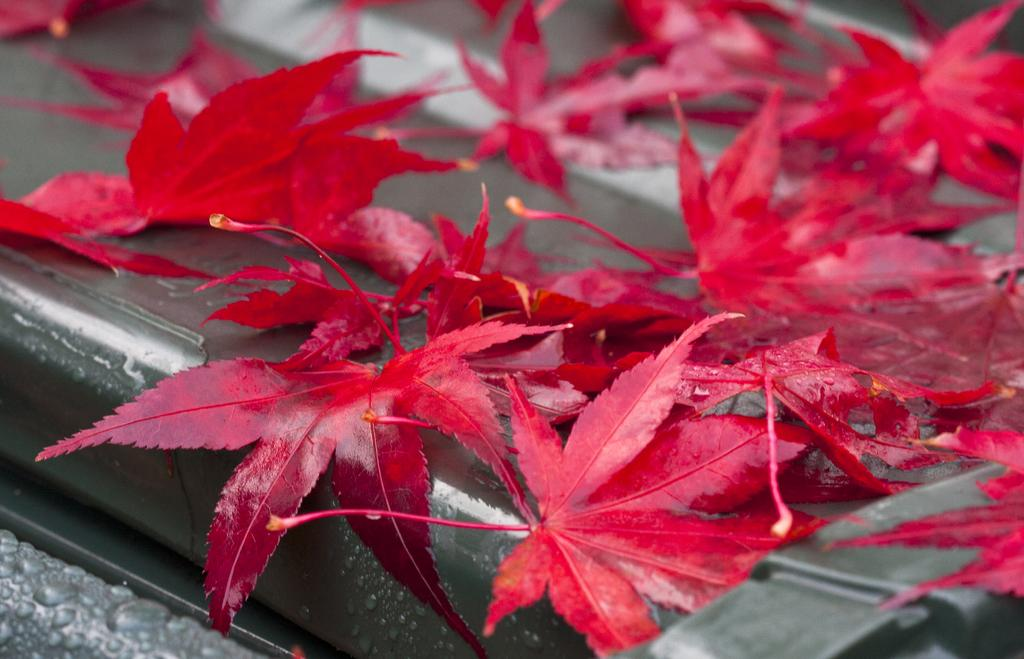What type of objects can be seen in the picture? There are leaves in the picture. What is the color of the leaves? The leaves are red in color. Is there a veil covering the leaves in the picture? No, there is no veil present in the image. The image only features red leaves. 